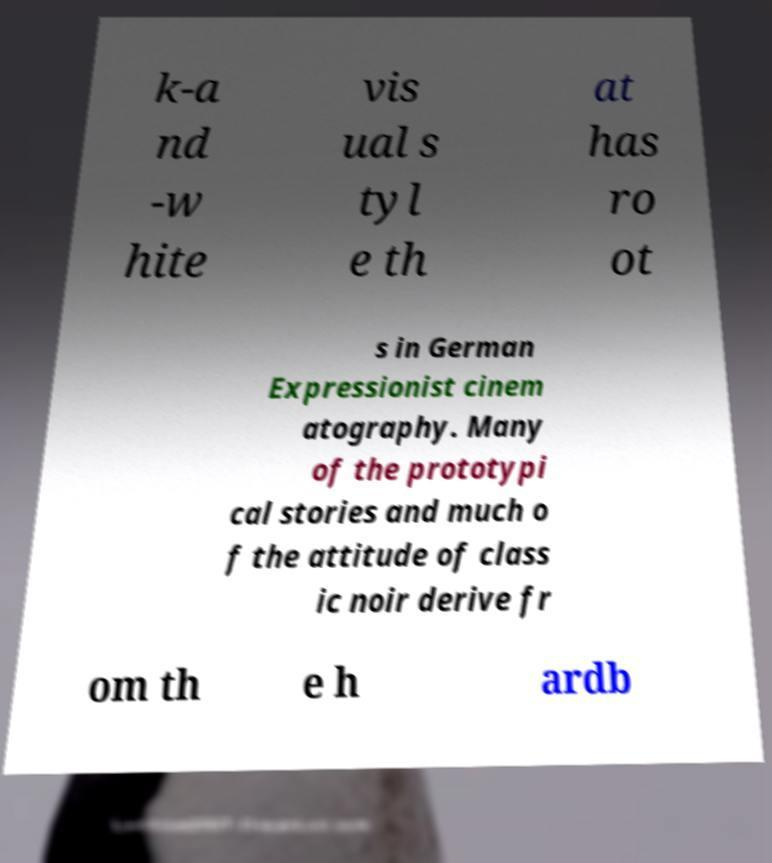For documentation purposes, I need the text within this image transcribed. Could you provide that? k-a nd -w hite vis ual s tyl e th at has ro ot s in German Expressionist cinem atography. Many of the prototypi cal stories and much o f the attitude of class ic noir derive fr om th e h ardb 